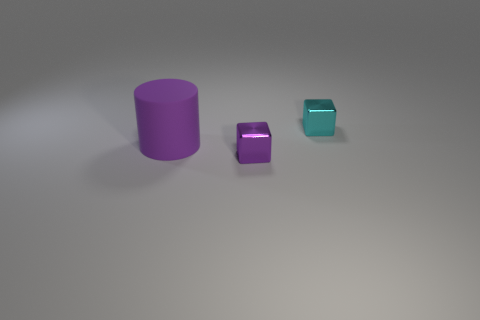How many objects are there in the image, and can you describe their shapes? There are three objects in the image: a large cylinder, a medium-sized cube, and a smaller cube. 